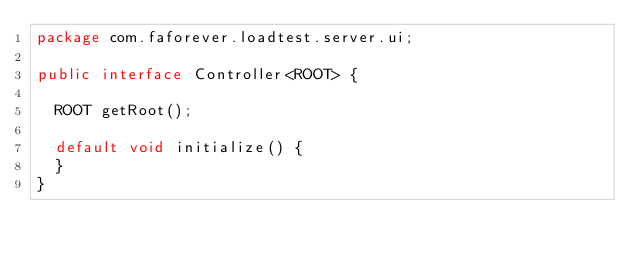<code> <loc_0><loc_0><loc_500><loc_500><_Java_>package com.faforever.loadtest.server.ui;

public interface Controller<ROOT> {

  ROOT getRoot();

  default void initialize() {
  }
}
</code> 